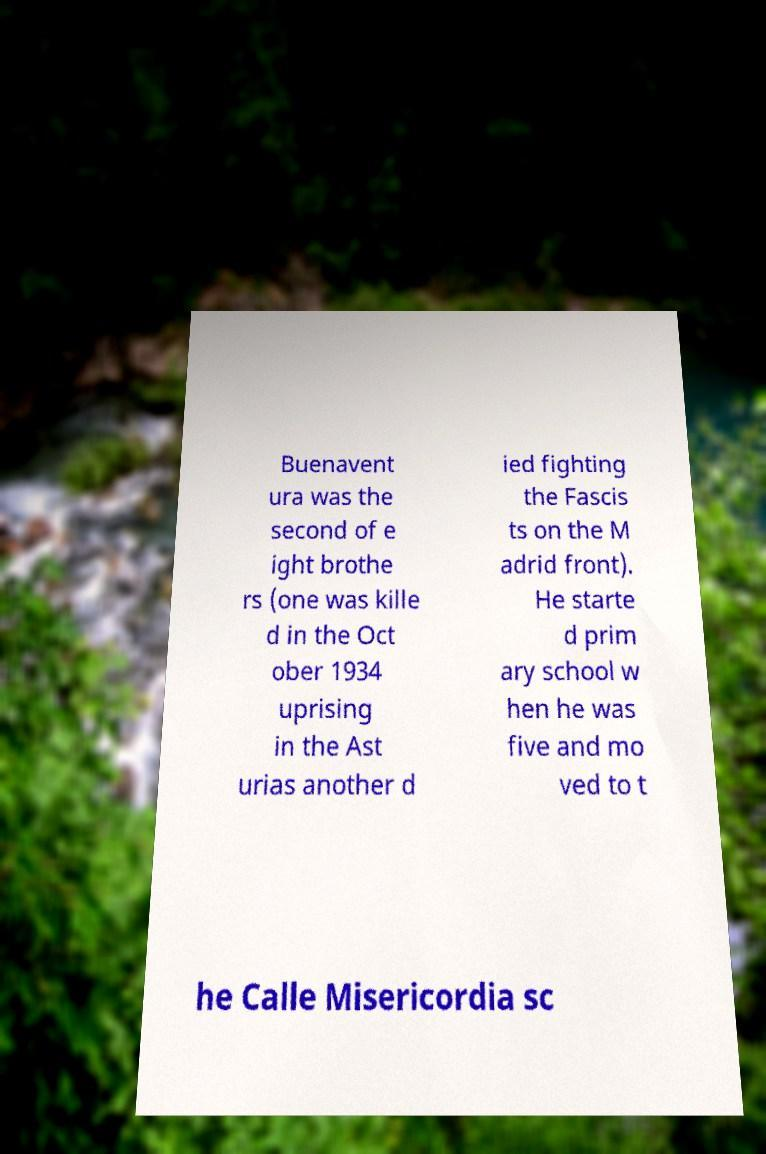Please read and relay the text visible in this image. What does it say? Buenavent ura was the second of e ight brothe rs (one was kille d in the Oct ober 1934 uprising in the Ast urias another d ied fighting the Fascis ts on the M adrid front). He starte d prim ary school w hen he was five and mo ved to t he Calle Misericordia sc 